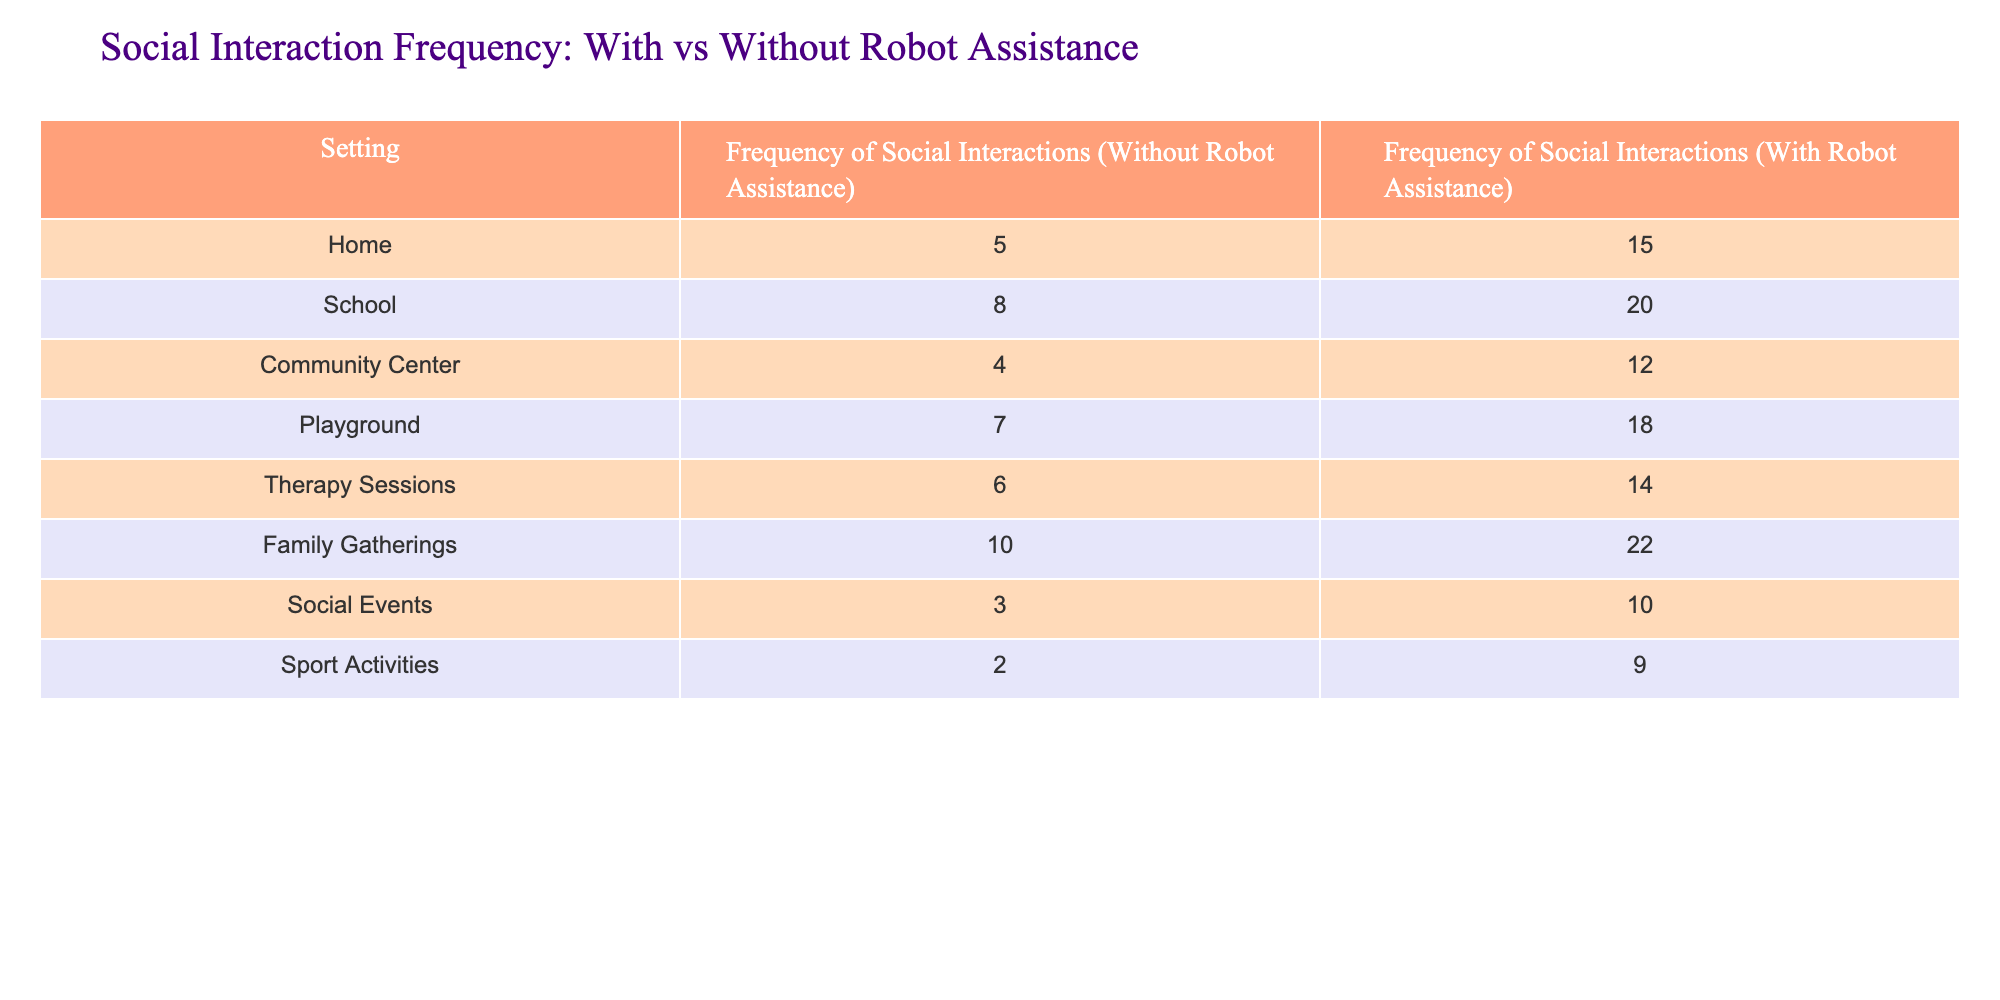What is the frequency of social interactions at home without robot assistance? The table indicates that the frequency of social interactions at home without robot assistance is listed directly under the respective column for home. The value for that entry is 5.
Answer: 5 What is the difference in frequency of social interactions at school with and without robot assistance? To find the difference, we subtract the frequency of social interactions without robot assistance (8) from the frequency with robot assistance (20). So, 20 - 8 = 12.
Answer: 12 Is the frequency of social interactions at the community center higher with robot assistance than at the playground without it? We need to compare the values: the frequency at the community center with robot assistance is 12, while the frequency at the playground without it is 7. Since 12 is greater than 7, the statement is true.
Answer: Yes What is the total frequency of social interactions with robot assistance across all settings? We sum all the frequencies with robot assistance: 15 (home) + 20 (school) + 12 (community center) + 18 (playground) + 14 (therapy sessions) + 22 (family gatherings) + 10 (social events) + 9 (sport activities) = 120. Therefore, the total frequency is 120.
Answer: 120 What is the average frequency of social interactions without robot assistance? To calculate the average, we first sum the frequencies without robot assistance: 5 + 8 + 4 + 7 + 6 + 10 + 3 + 2 = 45. There are 8 settings in total. So, 45 ÷ 8 = 5.625. The average frequency is approximately 5.63.
Answer: 5.63 How many settings have a higher frequency of social interactions with robot assistance compared to without it? We need to count the number of settings where the frequency with assistance is greater than without it. Looking at the table, all settings except sport activities (9 vs 2) and social events (10 vs 3) show a higher frequency with assistance. That gives us 6 settings: home, school, community center, playground, therapy sessions, and family gatherings.
Answer: 6 What is the maximum frequency of social interactions without robot assistance? The maximum value in the column for social interactions without robot assistance is found by scanning all the values: 5, 8, 4, 7, 6, 10, 3, and 2. The highest among these is 10.
Answer: 10 What is the frequency of social interactions during family gatherings with robot assistance? The frequency during family gatherings with robot assistance can be found directly in the table under the respective column. The value is 22.
Answer: 22 